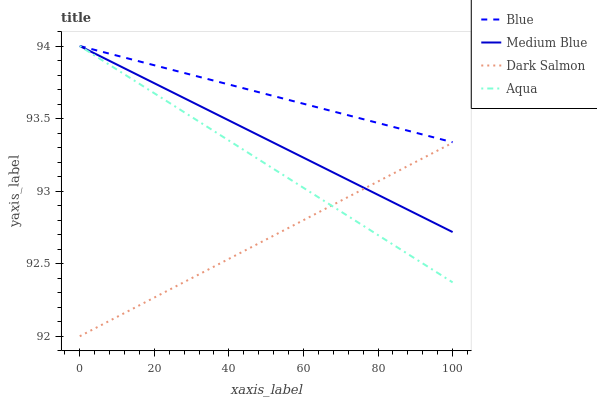Does Dark Salmon have the minimum area under the curve?
Answer yes or no. Yes. Does Blue have the maximum area under the curve?
Answer yes or no. Yes. Does Aqua have the minimum area under the curve?
Answer yes or no. No. Does Aqua have the maximum area under the curve?
Answer yes or no. No. Is Aqua the smoothest?
Answer yes or no. Yes. Is Medium Blue the roughest?
Answer yes or no. Yes. Is Medium Blue the smoothest?
Answer yes or no. No. Is Aqua the roughest?
Answer yes or no. No. Does Dark Salmon have the lowest value?
Answer yes or no. Yes. Does Aqua have the lowest value?
Answer yes or no. No. Does Medium Blue have the highest value?
Answer yes or no. Yes. Does Dark Salmon have the highest value?
Answer yes or no. No. Is Dark Salmon less than Blue?
Answer yes or no. Yes. Is Blue greater than Dark Salmon?
Answer yes or no. Yes. Does Aqua intersect Medium Blue?
Answer yes or no. Yes. Is Aqua less than Medium Blue?
Answer yes or no. No. Is Aqua greater than Medium Blue?
Answer yes or no. No. Does Dark Salmon intersect Blue?
Answer yes or no. No. 